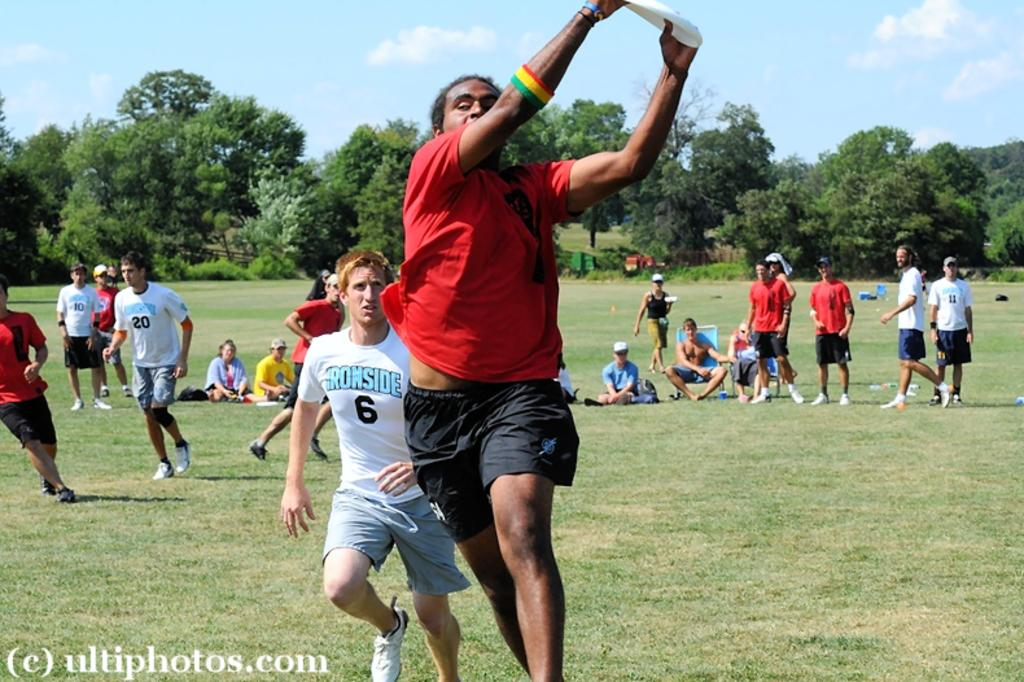Provide a one-sentence caption for the provided image. The frisbee player with the white shirt that says Ironside is behind the one with the red shirt. 